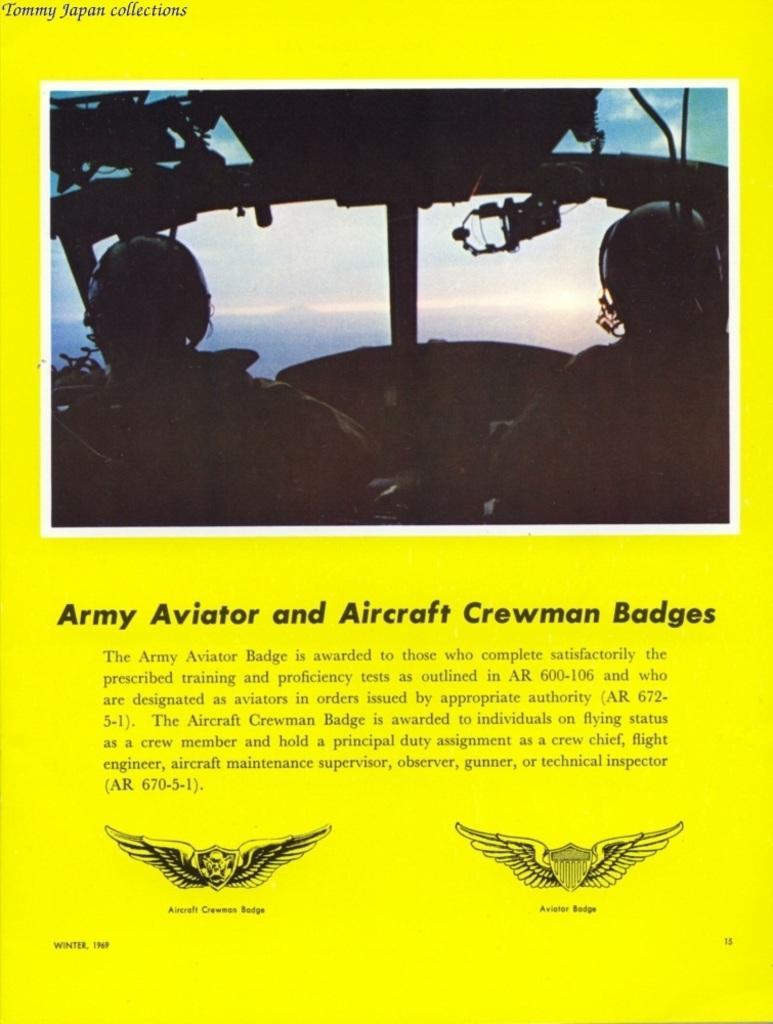Can you describe this image briefly? This is poster. Something written on this poster. Here we can see logos. In this picture we can see two people. 